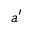Convert formula to latex. <formula><loc_0><loc_0><loc_500><loc_500>a ^ { \prime }</formula> 